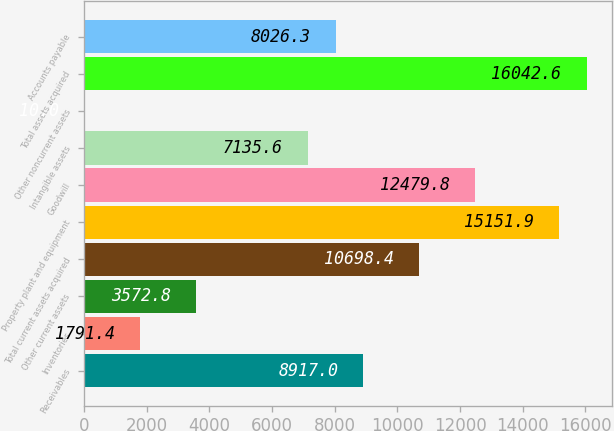<chart> <loc_0><loc_0><loc_500><loc_500><bar_chart><fcel>Receivables<fcel>Inventories<fcel>Other current assets<fcel>Total current assets acquired<fcel>Property plant and equipment<fcel>Goodwill<fcel>Intangible assets<fcel>Other noncurrent assets<fcel>Total assets acquired<fcel>Accounts payable<nl><fcel>8917<fcel>1791.4<fcel>3572.8<fcel>10698.4<fcel>15151.9<fcel>12479.8<fcel>7135.6<fcel>10<fcel>16042.6<fcel>8026.3<nl></chart> 